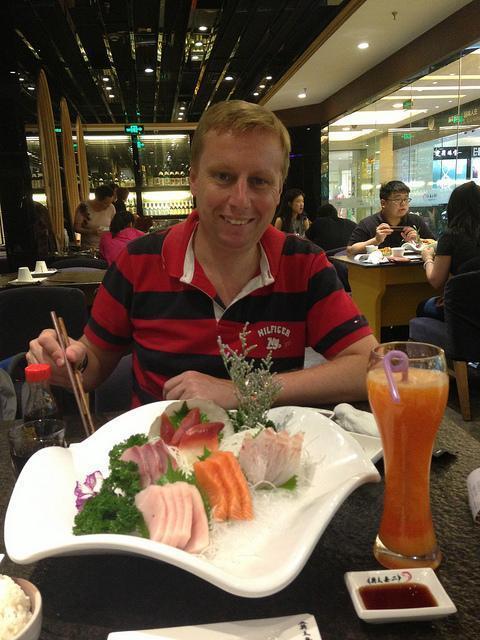How many pieces of salmon are on his plate?
Give a very brief answer. 3. How many bowls are in the photo?
Give a very brief answer. 2. How many chairs are there?
Give a very brief answer. 2. How many cups can you see?
Give a very brief answer. 2. How many people are there?
Give a very brief answer. 3. How many dining tables are there?
Give a very brief answer. 2. 